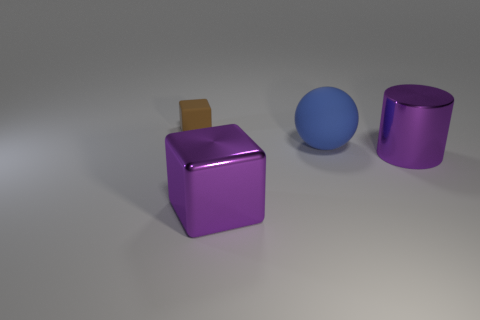There is a purple thing that is to the right of the large blue rubber ball; how big is it?
Offer a very short reply. Large. Does the cylinder have the same color as the big object that is left of the big matte ball?
Your response must be concise. Yes. Is there a tiny block that has the same color as the big matte object?
Keep it short and to the point. No. Does the blue sphere have the same material as the large purple thing on the left side of the large matte sphere?
Ensure brevity in your answer.  No. How many tiny things are either blue matte cylinders or brown objects?
Your answer should be very brief. 1. What is the material of the object that is the same color as the big cylinder?
Offer a terse response. Metal. Are there fewer large matte balls than tiny matte spheres?
Your response must be concise. No. There is a block right of the small brown object; is it the same size as the rubber thing that is in front of the tiny brown rubber thing?
Give a very brief answer. Yes. What number of purple objects are big metallic things or large cubes?
Your answer should be very brief. 2. What is the size of the shiny cube that is the same color as the big cylinder?
Your response must be concise. Large. 